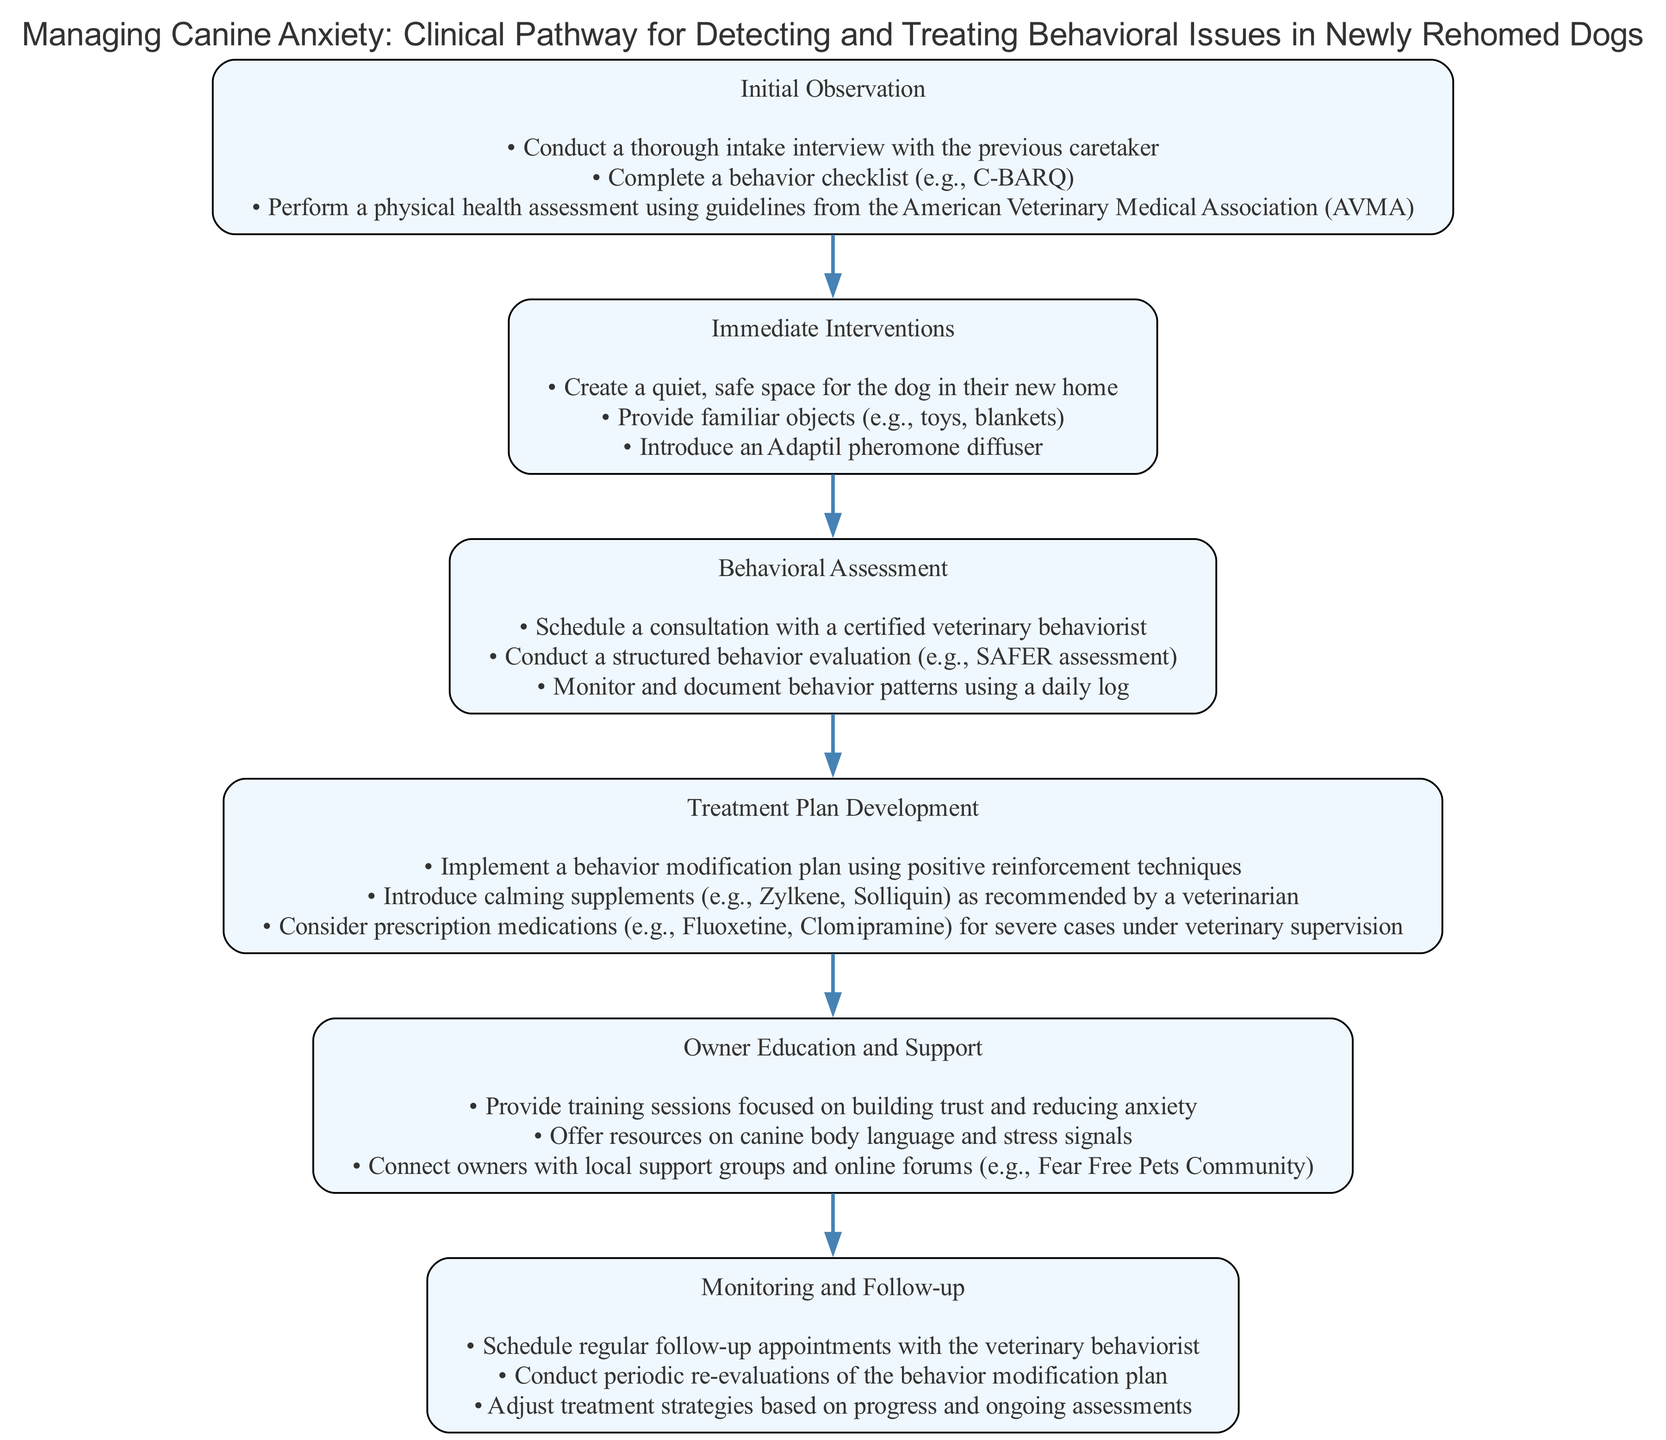What is the first stage of the clinical pathway? The first stage is labeled in the diagram as "Initial Observation." It is found at the top of the flow, making it the starting point of the pathway.
Answer: Initial Observation How many actions are listed under "Owner Education and Support"? By counting the bullet points listed under "Owner Education and Support," there are three distinct actions presented in that stage.
Answer: 3 What is the last stage in the clinical pathway? The last stage is indicated at the bottom of the flow diagram as the final node of the pathway after all other stages have been processed.
Answer: Monitoring and Follow-up Which action is recommended immediately after creating a safe space for the dog? Following the establishment of a quiet space, the subsequent action is to provide familiar objects to the dog, which helps in reducing anxiety further.
Answer: Provide familiar objects What types of interventions are suggested in the "Immediate Interventions" stage? Evaluating the actions listed in this stage, the diagram emphasizes creating a safe space, providing familiar objects, and introducing a calming pheromone diffuser as interventions for the dog.
Answer: Create a quiet space, provide familiar objects, introduce an Adaptil pheromone diffuser What is the relationship between "Behavioral Assessment" and "Treatment Plan Development"? The flow of the diagram shows that "Behavioral Assessment" directly precedes "Treatment Plan Development," indicating that the assessment informs the creation of the treatment plan.
Answer: Sequential relationship What are calming supplements mentioned in the treatment plan? In the Treatment Plan Development stage, the diagram specifically mentions Zylkene and Solliquin as examples of calming supplements recommended for the dog.
Answer: Zylkene, Solliquin Which professional is suggested for consultation during the "Behavioral Assessment" stage? The diagram specifies that a consultation with a certified veterinary behaviorist is necessary, pointing out the expertise needed at this stage in assessing the dog's behavior.
Answer: Certified veterinary behaviorist What type of action is implemented in the "Treatment Plan Development"? The actions listed under "Treatment Plan Development" involve formulating a behavior modification plan using positive reinforcement techniques, which is categorized as a treatment-related action.
Answer: Behavior modification plan using positive reinforcement techniques 